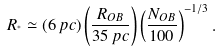Convert formula to latex. <formula><loc_0><loc_0><loc_500><loc_500>R _ { ^ { * } } \simeq ( 6 \, p c ) \left ( \frac { R _ { O B } } { 3 5 \, p c } \right ) \left ( \frac { N _ { O B } } { 1 0 0 } \right ) ^ { - 1 / 3 } .</formula> 